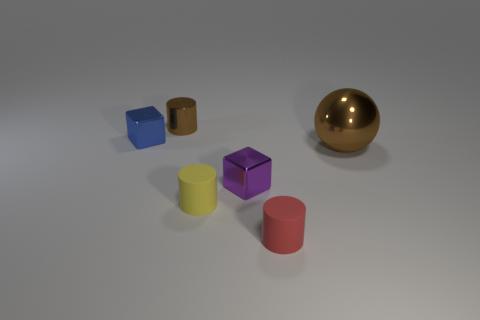What is the size of the cylinder that is the same color as the big ball?
Your answer should be very brief. Small. What material is the purple cube?
Give a very brief answer. Metal. Do the brown thing left of the sphere and the small yellow object have the same material?
Offer a terse response. No. Are there fewer metallic cubes that are to the left of the small yellow object than green rubber cylinders?
Offer a terse response. No. The block that is the same size as the blue object is what color?
Make the answer very short. Purple. What number of blue things have the same shape as the purple metal thing?
Your answer should be compact. 1. What is the color of the block that is to the left of the small yellow cylinder?
Give a very brief answer. Blue. How many shiny objects are tiny blue things or purple cylinders?
Give a very brief answer. 1. What shape is the tiny shiny thing that is the same color as the ball?
Your answer should be very brief. Cylinder. How many blue shiny cubes have the same size as the brown sphere?
Your response must be concise. 0. 